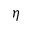<formula> <loc_0><loc_0><loc_500><loc_500>\eta</formula> 